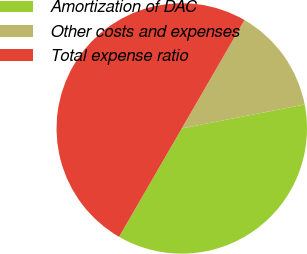Convert chart to OTSL. <chart><loc_0><loc_0><loc_500><loc_500><pie_chart><fcel>Amortization of DAC<fcel>Other costs and expenses<fcel>Total expense ratio<nl><fcel>36.41%<fcel>13.59%<fcel>50.0%<nl></chart> 